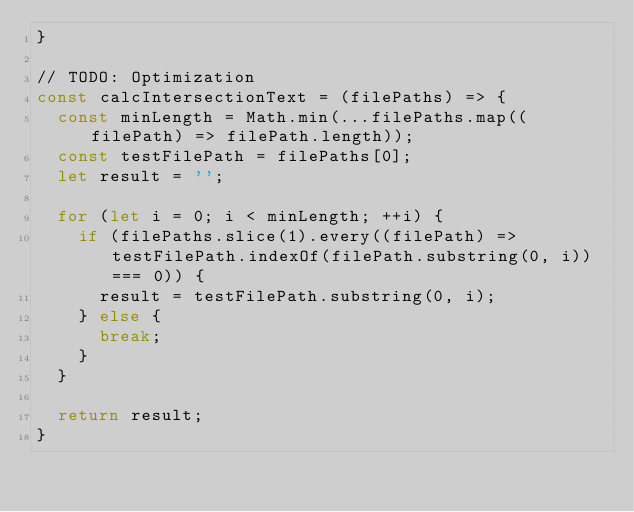Convert code to text. <code><loc_0><loc_0><loc_500><loc_500><_JavaScript_>}

// TODO: Optimization
const calcIntersectionText = (filePaths) => {
  const minLength = Math.min(...filePaths.map((filePath) => filePath.length));
  const testFilePath = filePaths[0];
  let result = '';

  for (let i = 0; i < minLength; ++i) {
    if (filePaths.slice(1).every((filePath) => testFilePath.indexOf(filePath.substring(0, i)) === 0)) {
      result = testFilePath.substring(0, i);
    } else {
      break;
    }
  }

  return result;
}
</code> 